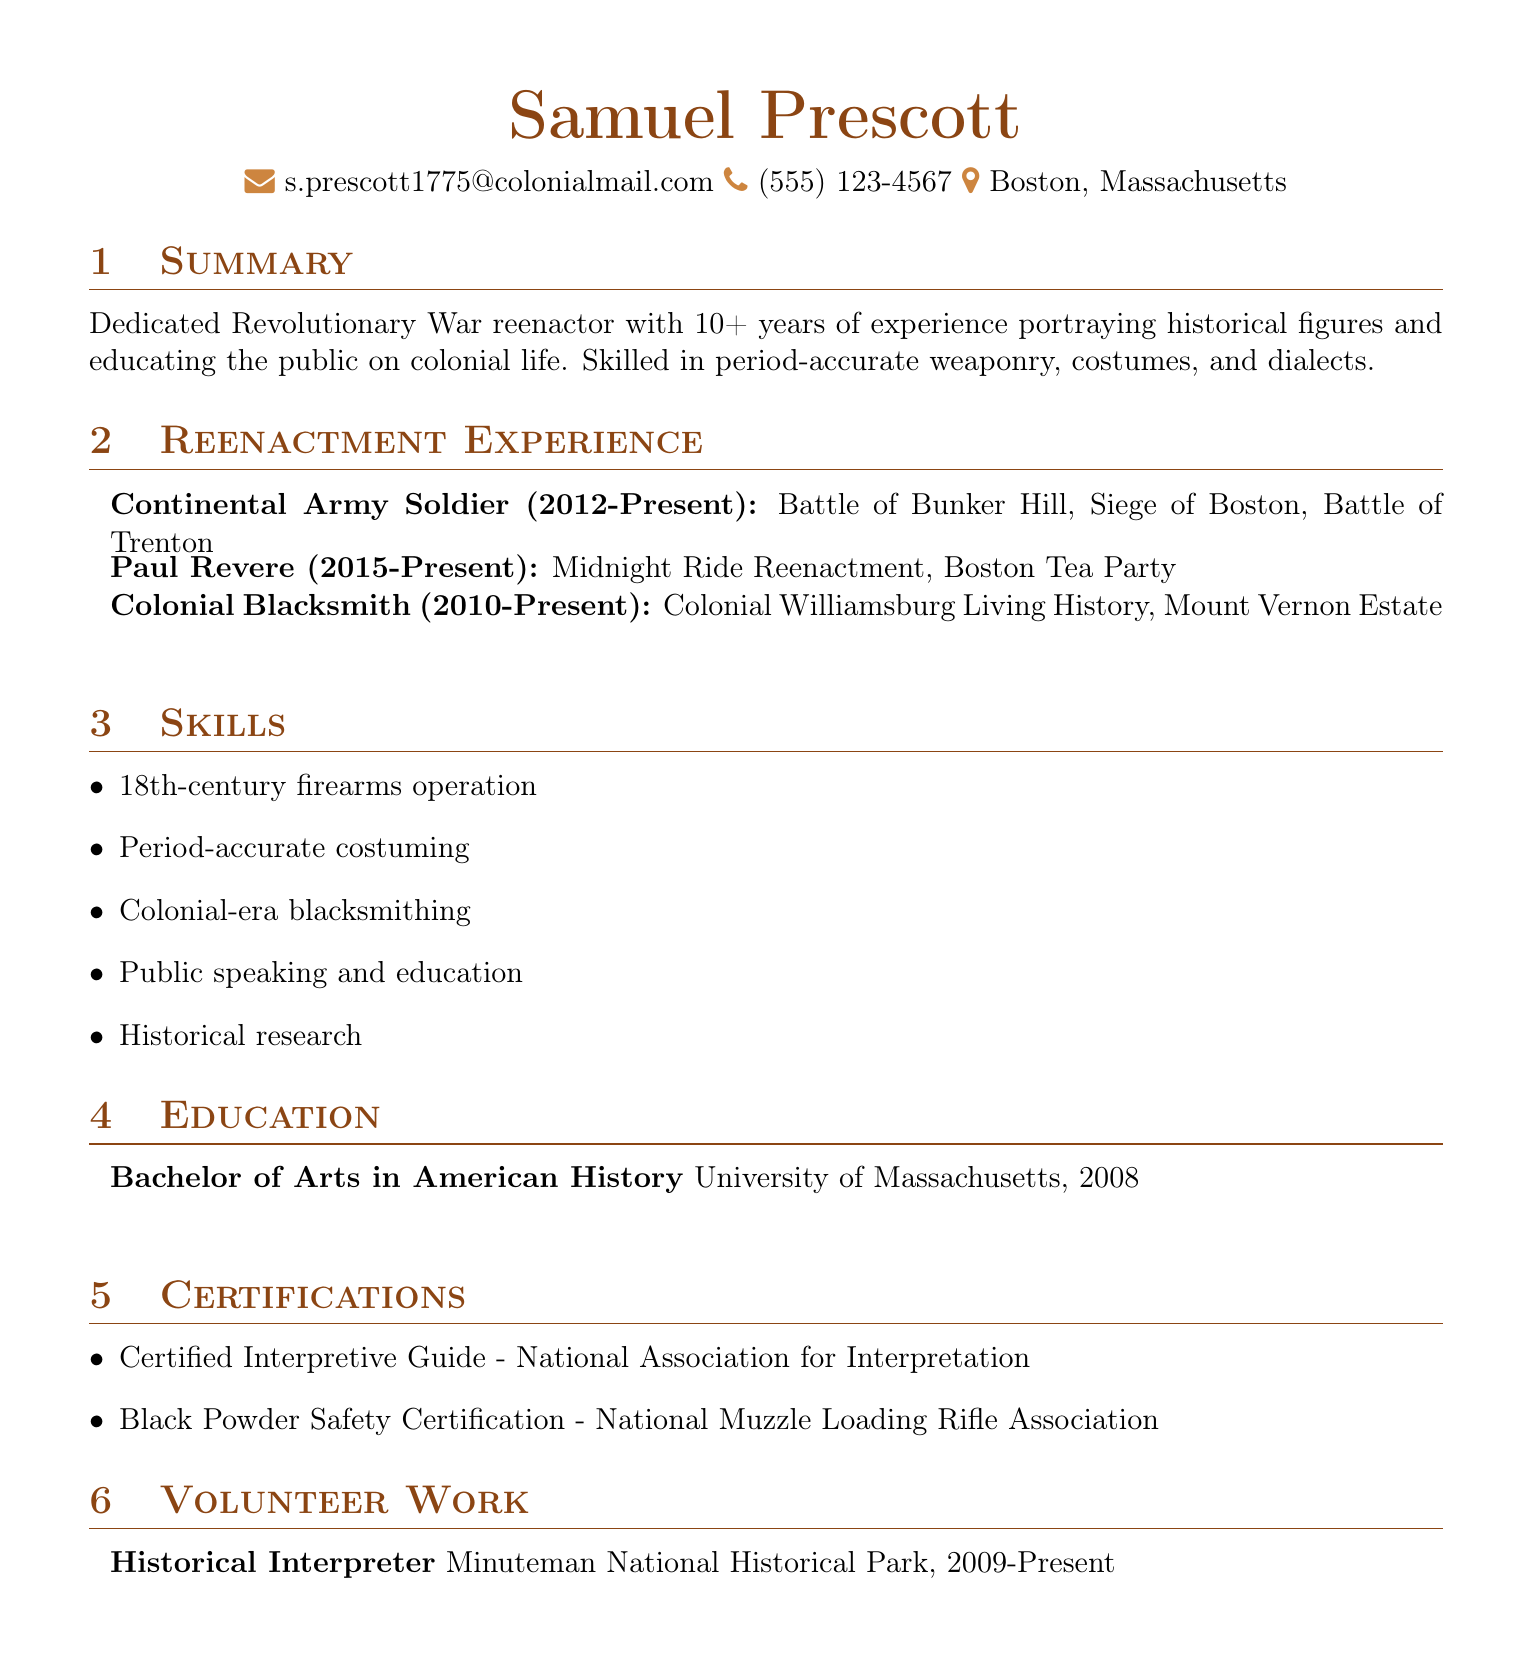What is the name of the individual? The name is highlighted at the top of the document, identifying the individual.
Answer: Samuel Prescott How many years of reenactment experience does Samuel Prescott have? The summary states that he has over 10 years of experience in reenactments.
Answer: 10+ Which battles did he participate in as a Continental Army Soldier? The reenactment experience section lists specific battles he took part in under this role.
Answer: Battle of Bunker Hill, Siege of Boston, Battle of Trenton What role does he play during the Midnight Ride Reenactment? This is specified in the reenactment experience section, indicating his historical portrayal.
Answer: Paul Revere Where did he obtain his degree? The education section lists the institution where he earned his degree.
Answer: University of Massachusetts What certification does he have related to black powder safety? The certifications section specifies his relevant certification.
Answer: Black Powder Safety Certification In what year did he start working as a Historical Interpreter at Minuteman National Historical Park? The volunteer work section provides the starting year for this role.
Answer: 2009 What skill is associated with Colonial-era crafting? The skills section highlights specific abilities he possesses related to colonial crafts.
Answer: Colonial-era blacksmithing How long has he been participating in reenactments as a Colonial Blacksmith? This duration is defined in the reenactment experience section.
Answer: 2010-Present 